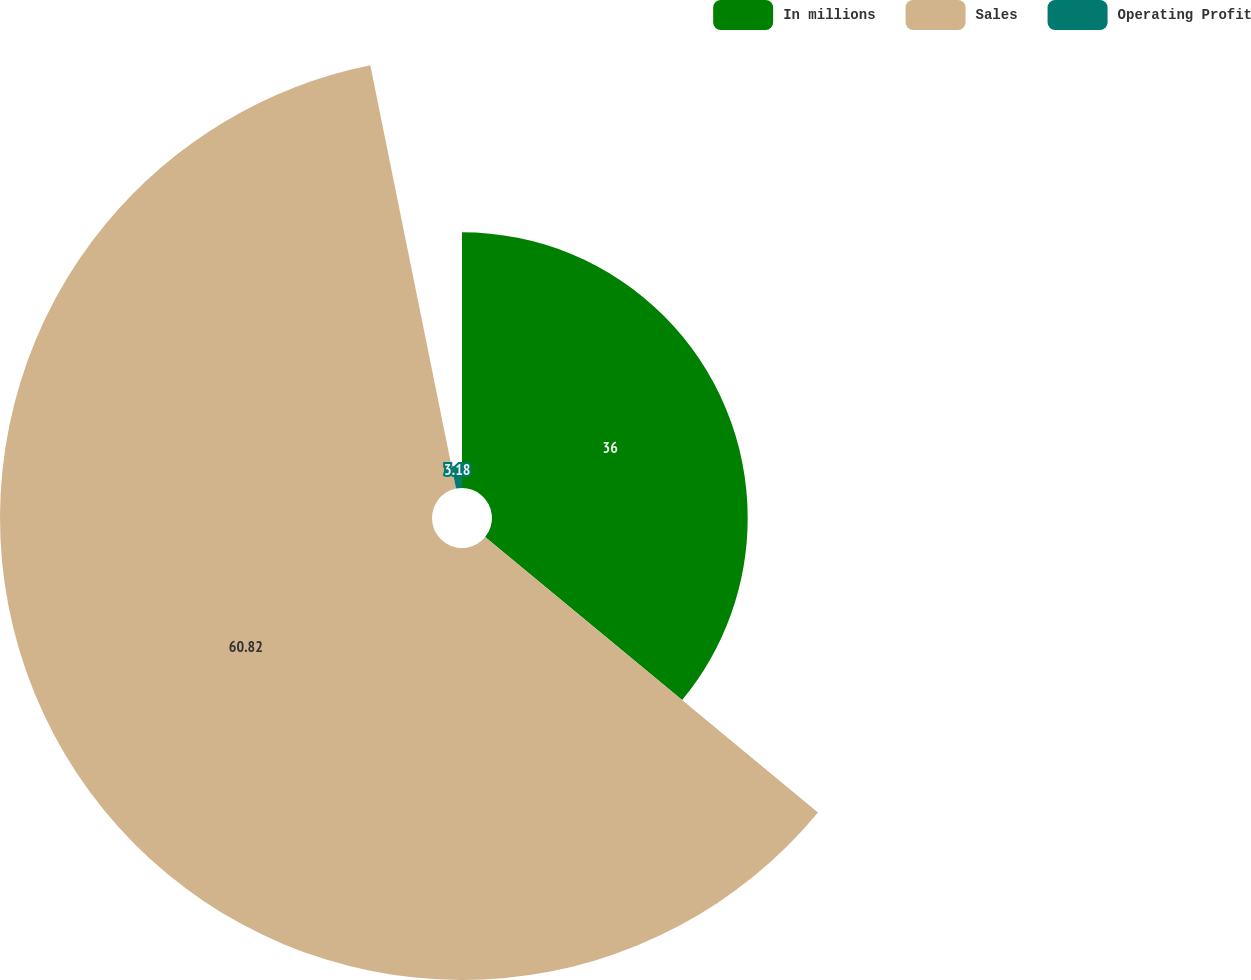Convert chart to OTSL. <chart><loc_0><loc_0><loc_500><loc_500><pie_chart><fcel>In millions<fcel>Sales<fcel>Operating Profit<nl><fcel>36.0%<fcel>60.82%<fcel>3.18%<nl></chart> 